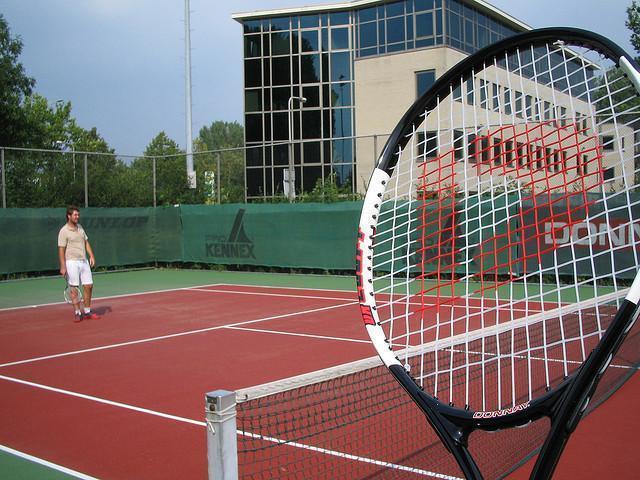Who plays this sport?
Select the accurate answer and provide justification: `Answer: choice
Rationale: srationale.`
Options: Serena williams, bo jackson, pele, marian hossa. Answer: serena williams.
Rationale: Serena williams is famous for playing tennis. 